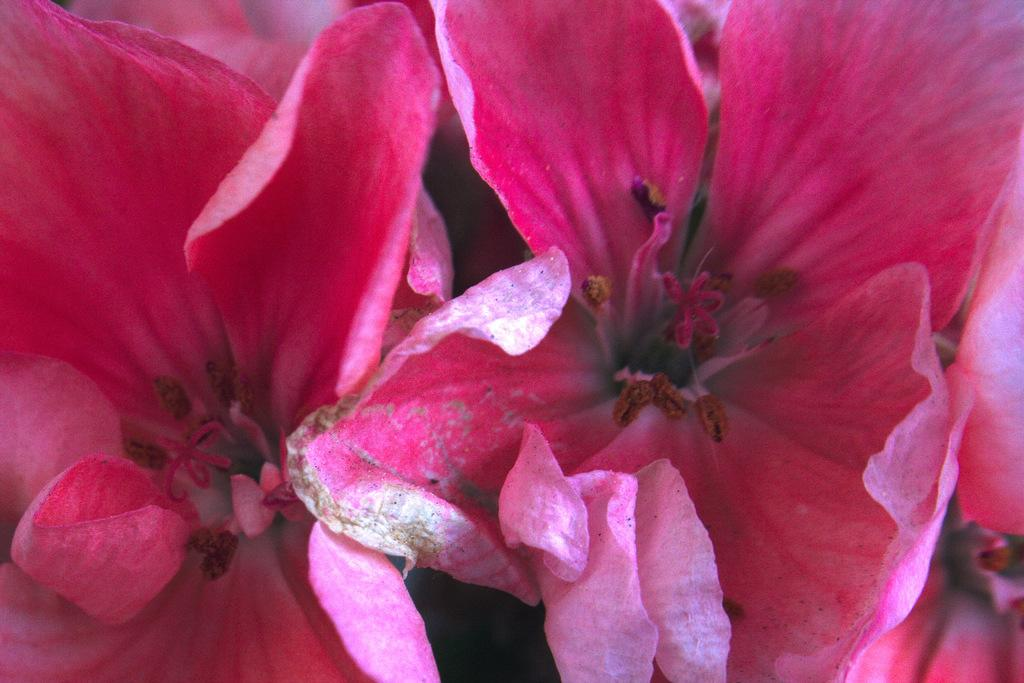What type of flowers can be seen in the image? There are pink color flowers in the image. What activity are the children participating in while enjoying the weather in the image? There are no children or weather mentioned in the image; it only features pink color flowers. 